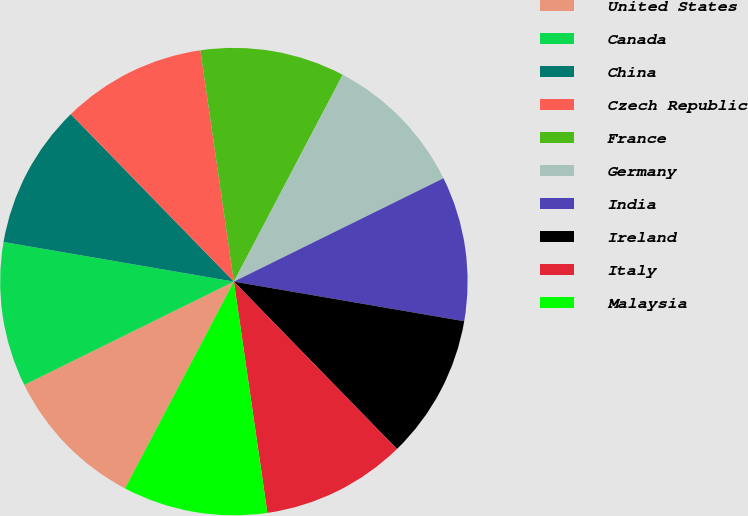<chart> <loc_0><loc_0><loc_500><loc_500><pie_chart><fcel>United States<fcel>Canada<fcel>China<fcel>Czech Republic<fcel>France<fcel>Germany<fcel>India<fcel>Ireland<fcel>Italy<fcel>Malaysia<nl><fcel>10.0%<fcel>10.0%<fcel>10.0%<fcel>10.0%<fcel>10.0%<fcel>10.0%<fcel>10.0%<fcel>10.0%<fcel>10.0%<fcel>10.0%<nl></chart> 